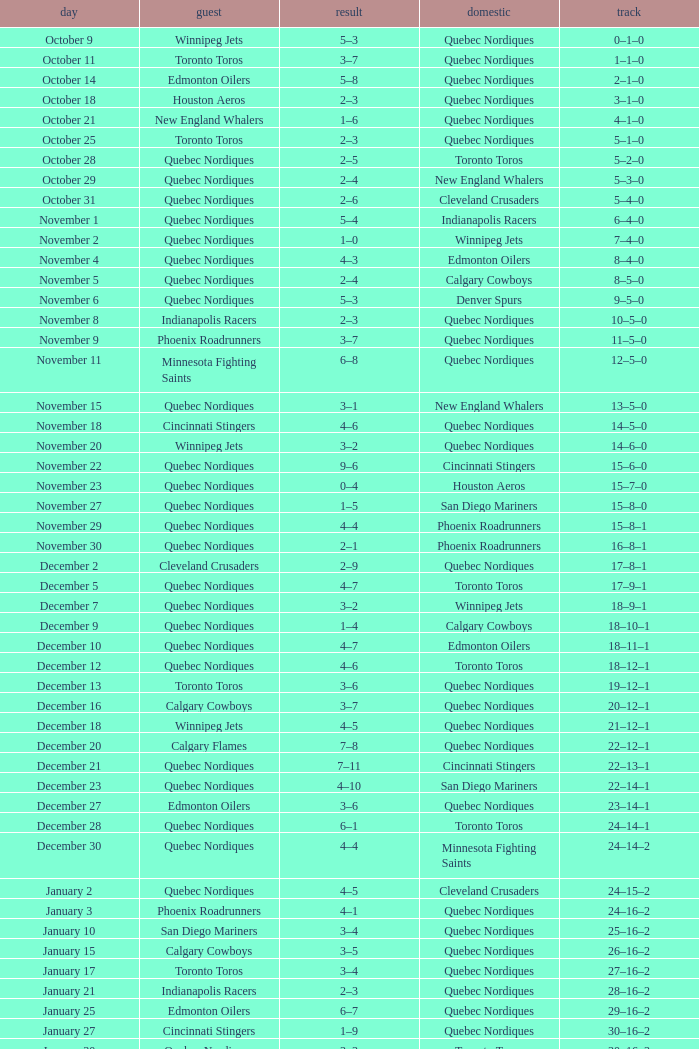What was the score of the game when the record was 39–21–4? 5–4. 